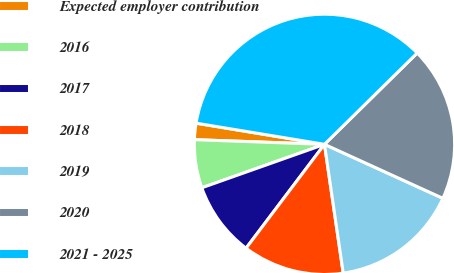Convert chart to OTSL. <chart><loc_0><loc_0><loc_500><loc_500><pie_chart><fcel>Expected employer contribution<fcel>2016<fcel>2017<fcel>2018<fcel>2019<fcel>2020<fcel>2021 - 2025<nl><fcel>2.03%<fcel>5.99%<fcel>9.29%<fcel>12.59%<fcel>15.89%<fcel>19.19%<fcel>35.02%<nl></chart> 